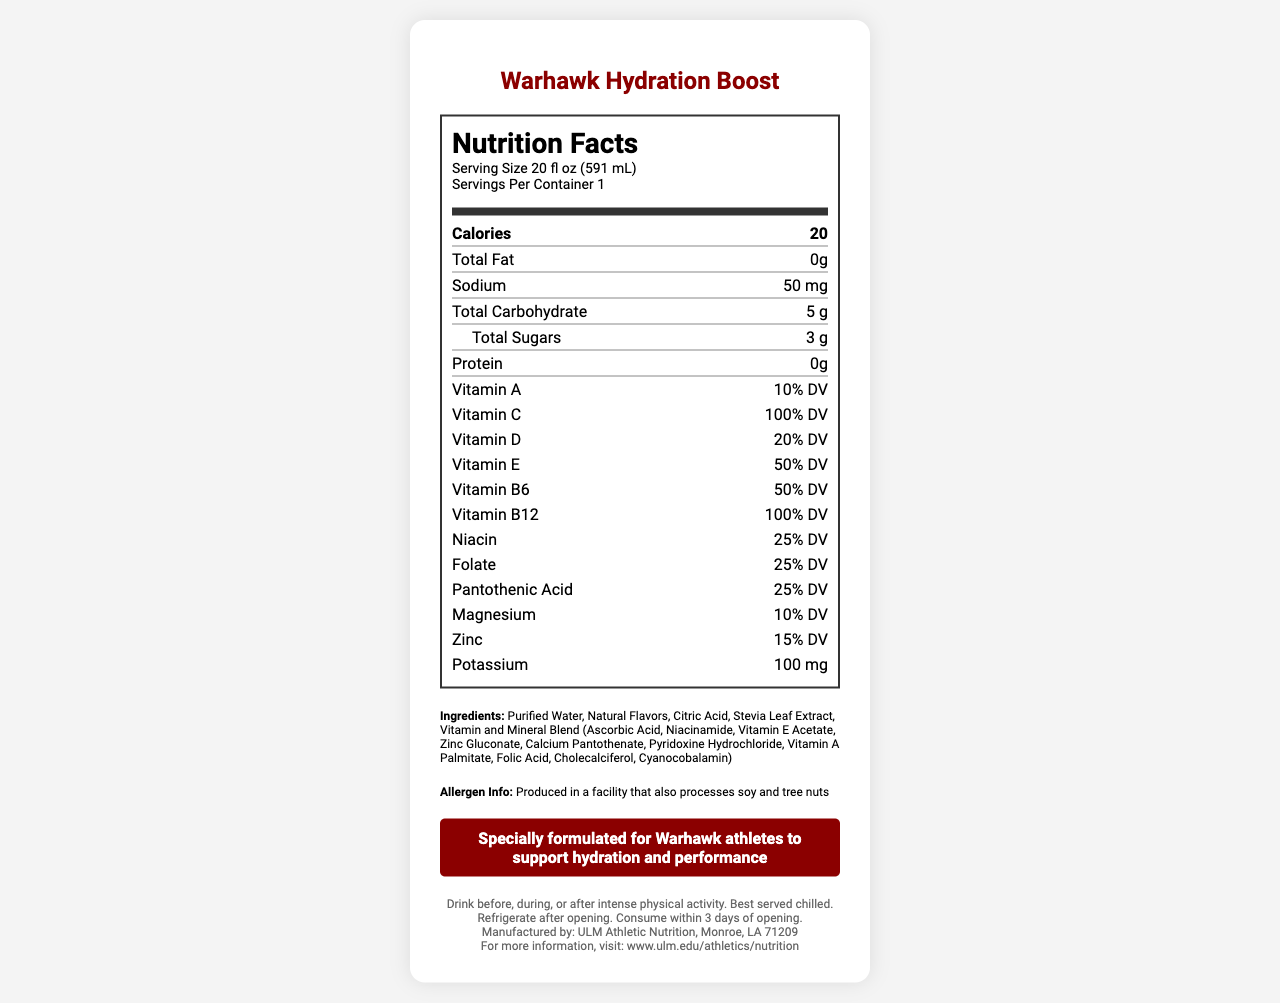how many calories are in one serving? The document specifies that there are 20 calories in a serving size of 20 fl oz (591 mL).
Answer: 20 what is the serving size of Warhawk Hydration Boost? The document mentions that the serving size is 20 fl oz (591 mL).
Answer: 20 fl oz (591 mL) how much sodium is in Warhawk Hydration Boost? The document lists sodium content as 50 mg.
Answer: 50 mg which vitamin is present at the highest percentage of the daily value? The document shows that Vitamin C is at 100% Daily Value, which is the highest among all listed vitamins.
Answer: Vitamin C what is the main marketing claim of Warhawk Hydration Boost? The marketing claim is highlighted in the document as specifically beneficial for Warhawk athletes.
Answer: Specially formulated for Warhawk athletes to support hydration and performance how many grams of total sugars does the product contain? A. 0g   B. 3g   C. 5g   D. 10g The document indicates that the total sugars content in the product is 3 grams.
Answer: B. 3g which of the following is an ingredient in Warhawk Hydration Boost? (select all that apply) I. Stevia Leaf Extract   II. High Fructose Corn Syrup   III. Ascorbic Acid   IV. Citric Acid The document lists Stevia Leaf Extract, Ascorbic Acid, and Citric Acid as ingredients.
Answer: I, III, IV is the product suitable for someone with tree nut allergies? The document states that the product is produced in a facility that processes soy and tree nuts, which may not make it suitable for someone with tree nut allergies.
Answer: No describe the main components of the Warhawk Hydration Boost Nutrition Facts Label The product aims to enhance hydration and performance targeted at athletes, with a detailed breakdown of its nutritional profile, key ingredients, and allergen information.
Answer: Warhawk Hydration Boost is a vitamin-enriched water formulated for athletes, offering 20 calories per serving, with key vitamins such as Vitamin C (100% DV), Vitamin B12 (100% DV), and an electrolyte blend. Ingredients include purified water, natural flavors, and a vitamin/mineral blend. The drink is low in sugars, fat-free, gluten-free, and contains essential minerals like magnesium and potassium. what is the full address of the manufacturer? The manufacturer's full address is Monroe, LA 71209.
Answer: Monroe, LA 71209 who manufactures Warhawk Hydration Boost? The manufacturer is listed as ULM Athletic Nutrition, Monroe, LA 71209.
Answer: ULM Athletic Nutrition how much potassium is in one serving of Warhawk Hydration Boost? The document specifies that one serving contains 100 mg of potassium.
Answer: 100 mg what are the storage instructions for the product after opening? The document advises to refrigerate after opening and consume within 3 days.
Answer: Refrigerate after opening. Consume within 3 days of opening. what does the product's electrolyte blend contain? A. Sodium Chloride, Potassium Chloride, Magnesium Chloride   B. Sodium Citrate, Potassium Citrate, Magnesium Citrate   C. Sodium Sulfate, Potassium Sulfate, Magnesium Sulfate   D. Sodium Bicarbonate, Potassium Bicarbonate, Magnesium Bicarbonate The document identifies the electrolyte blend as Sodium Citrate, Potassium Citrate, and Magnesium Citrate.
Answer: B. Sodium Citrate, Potassium Citrate, Magnesium Citrate what is the total carbohydrate content per serving? The document lists the total carbohydrate content per serving as 5 grams.
Answer: 5 g can I consume this product after 5 days of opening if refrigerated? The document recommends consuming the product within 3 days of opening, even if refrigerated.
Answer: No does this product contain gluten? The document does not provide clear information on whether the product is gluten-free.
Answer: Not enough information which vitamin has the same percentage daily value as zinc in the product? Both magnesium and zinc have a daily value percentage of 10% and 15% respectively.
Answer: Magnesium what type of flavoring agents does Warhawk Hydration Boost use? According to the document, the product uses natural flavors.
Answer: Natural Flavors does the product contain any protein? The document states that the product contains 0 grams of protein.
Answer: No 